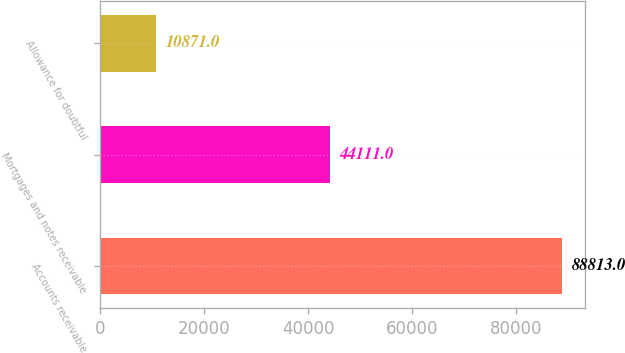Convert chart. <chart><loc_0><loc_0><loc_500><loc_500><bar_chart><fcel>Accounts receivable<fcel>Mortgages and notes receivable<fcel>Allowance for doubtful<nl><fcel>88813<fcel>44111<fcel>10871<nl></chart> 